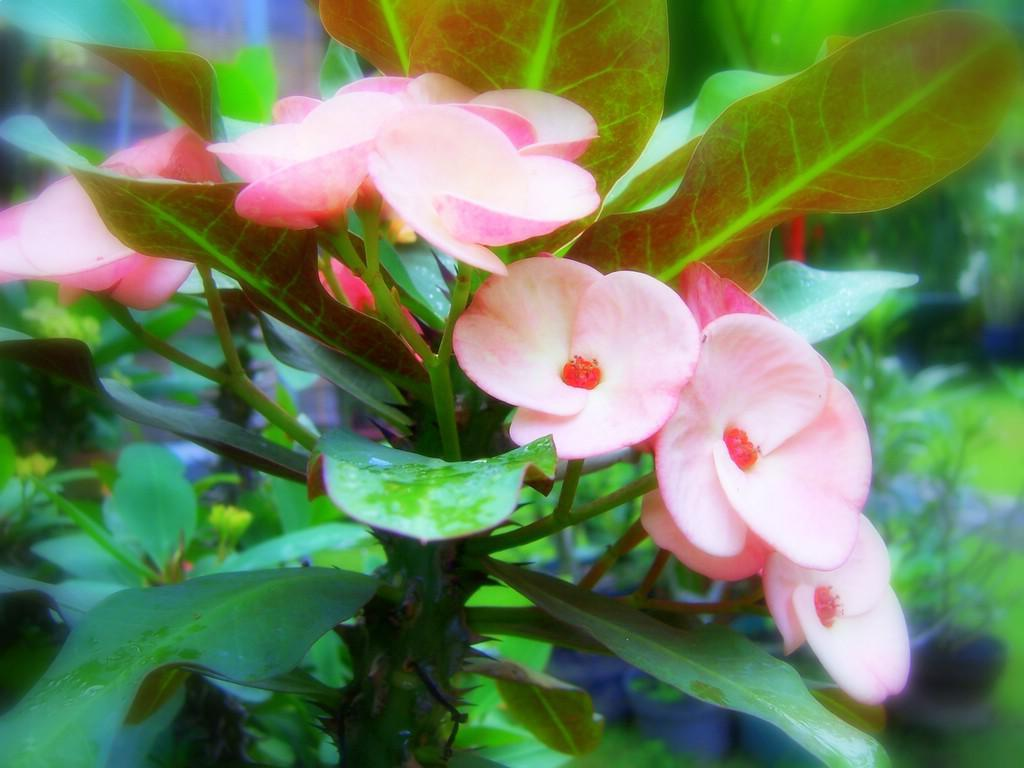What is visible in the foreground of the image? There are plants in the foreground of the image. What is visible in the background of the image? There are plants in the background of the image. What is the title of the book that is being read by the person in the image? There is no person or book present in the image; it features plants in the foreground and background. 